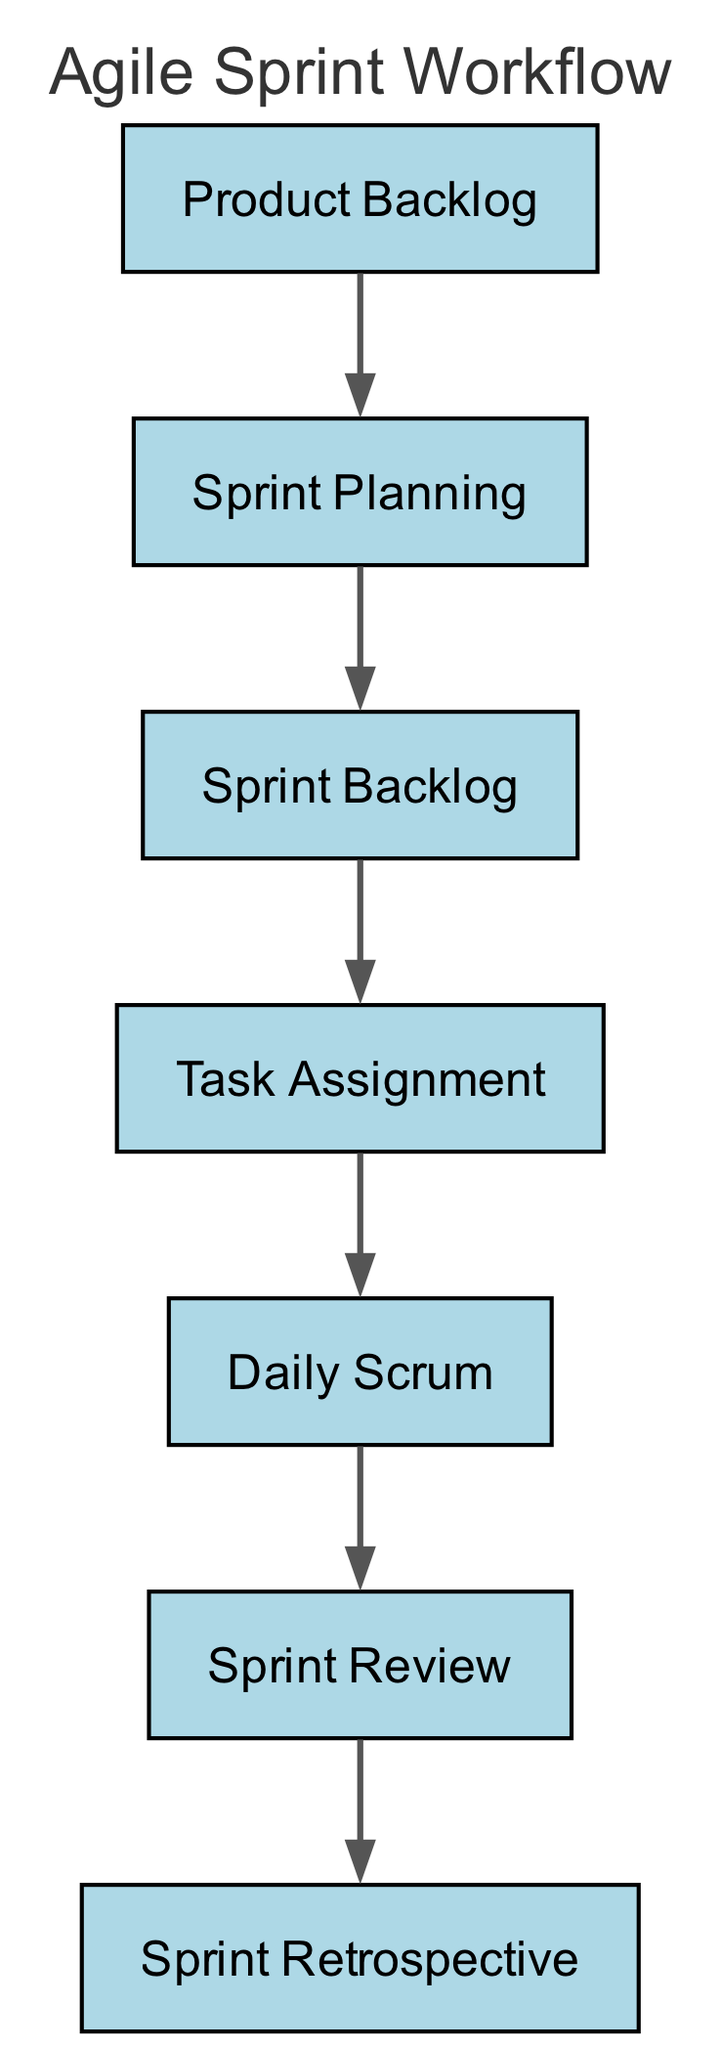What is the first step in the Agile sprint workflow? The first step is represented by the node labeled "Product Backlog," indicating the starting point of the workflow.
Answer: Product Backlog How many nodes are there in the diagram? The diagram consists of a total of seven nodes, which correspond to the different stages in the Agile sprint workflow.
Answer: 7 What does "Sprint Review" depend on? The "Sprint Review" node is dependent on the prior node "Daily Scrum," indicating the flow of the process.
Answer: Daily Scrum Which node immediately precedes "Task Assignment"? The node that comes just before "Task Assignment" is "Sprint Backlog." The relationship is direct, showing the progression of tasks.
Answer: Sprint Backlog What is the final stage in the Agile sprint workflow? The last step in this workflow as per the diagram is the "Sprint Retrospective," which reflects on the entire sprint process.
Answer: Sprint Retrospective How many edges are there in the diagram? There are six edges in the diagram, each representing the dependency relationship between the nodes.
Answer: 6 What is the relationship between "Sprint Planning" and "Product Backlog"? "Sprint Planning" preys on "Product Backlog," indicating that "Sprint Planning" occurs as a direct result of the "Product Backlog."
Answer: Sprint Planning preys on Product Backlog Which node is the only one without any preys on it? The "Product Backlog" is the only node without any preys on it, meaning it does not rely on any preceding node for its initiation.
Answer: Product Backlog 